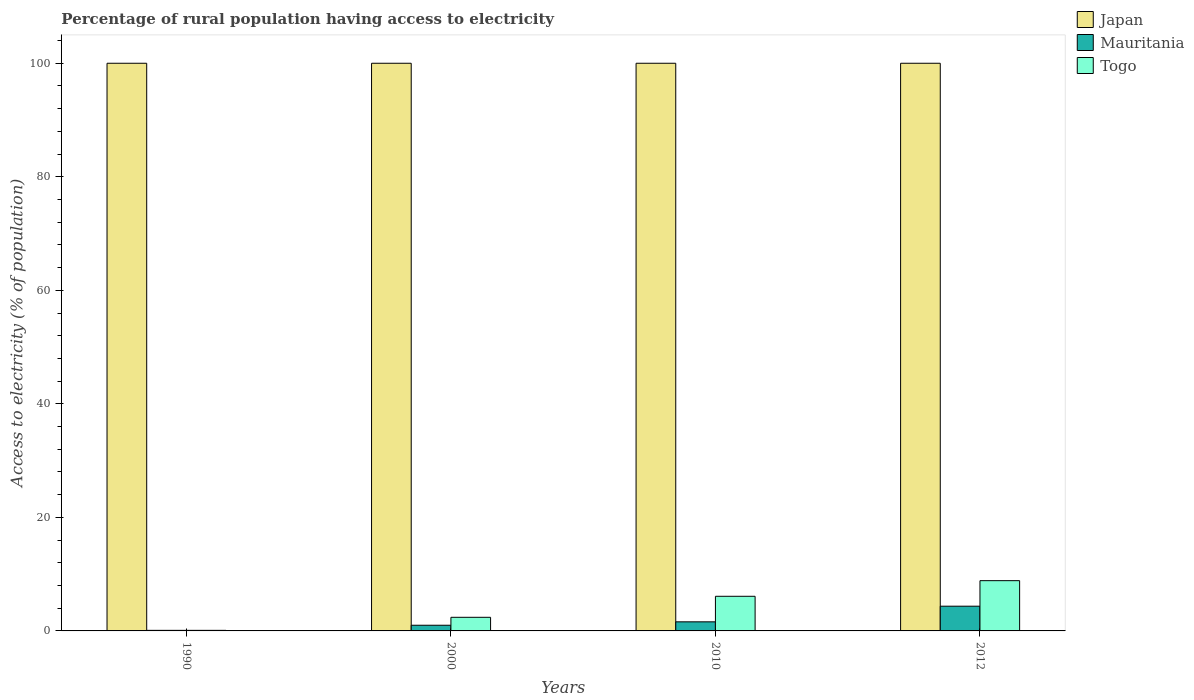How many different coloured bars are there?
Provide a succinct answer. 3. Are the number of bars on each tick of the X-axis equal?
Offer a terse response. Yes. How many bars are there on the 1st tick from the right?
Keep it short and to the point. 3. What is the label of the 1st group of bars from the left?
Your response must be concise. 1990. In how many cases, is the number of bars for a given year not equal to the number of legend labels?
Offer a terse response. 0. Across all years, what is the maximum percentage of rural population having access to electricity in Japan?
Keep it short and to the point. 100. Across all years, what is the minimum percentage of rural population having access to electricity in Japan?
Your answer should be very brief. 100. What is the total percentage of rural population having access to electricity in Japan in the graph?
Ensure brevity in your answer.  400. What is the difference between the percentage of rural population having access to electricity in Japan in 1990 and that in 2012?
Your response must be concise. 0. What is the difference between the percentage of rural population having access to electricity in Togo in 2000 and the percentage of rural population having access to electricity in Japan in 2012?
Your answer should be very brief. -97.6. What is the average percentage of rural population having access to electricity in Togo per year?
Your answer should be compact. 4.36. In the year 2000, what is the difference between the percentage of rural population having access to electricity in Mauritania and percentage of rural population having access to electricity in Japan?
Make the answer very short. -99. In how many years, is the percentage of rural population having access to electricity in Togo greater than 88 %?
Make the answer very short. 0. What is the ratio of the percentage of rural population having access to electricity in Togo in 1990 to that in 2012?
Provide a succinct answer. 0.01. Is the percentage of rural population having access to electricity in Mauritania in 2000 less than that in 2010?
Offer a very short reply. Yes. What is the difference between the highest and the second highest percentage of rural population having access to electricity in Japan?
Provide a succinct answer. 0. What is the difference between the highest and the lowest percentage of rural population having access to electricity in Mauritania?
Offer a very short reply. 4.25. In how many years, is the percentage of rural population having access to electricity in Togo greater than the average percentage of rural population having access to electricity in Togo taken over all years?
Ensure brevity in your answer.  2. Is the sum of the percentage of rural population having access to electricity in Togo in 2010 and 2012 greater than the maximum percentage of rural population having access to electricity in Japan across all years?
Offer a very short reply. No. What does the 2nd bar from the left in 2000 represents?
Make the answer very short. Mauritania. What does the 1st bar from the right in 1990 represents?
Provide a succinct answer. Togo. Is it the case that in every year, the sum of the percentage of rural population having access to electricity in Japan and percentage of rural population having access to electricity in Togo is greater than the percentage of rural population having access to electricity in Mauritania?
Provide a short and direct response. Yes. How many bars are there?
Give a very brief answer. 12. How many years are there in the graph?
Offer a terse response. 4. What is the difference between two consecutive major ticks on the Y-axis?
Offer a very short reply. 20. What is the title of the graph?
Offer a terse response. Percentage of rural population having access to electricity. Does "Seychelles" appear as one of the legend labels in the graph?
Give a very brief answer. No. What is the label or title of the Y-axis?
Provide a succinct answer. Access to electricity (% of population). What is the Access to electricity (% of population) in Togo in 1990?
Your response must be concise. 0.1. What is the Access to electricity (% of population) of Togo in 2000?
Your answer should be compact. 2.4. What is the Access to electricity (% of population) in Mauritania in 2010?
Give a very brief answer. 1.6. What is the Access to electricity (% of population) of Togo in 2010?
Provide a succinct answer. 6.1. What is the Access to electricity (% of population) of Japan in 2012?
Ensure brevity in your answer.  100. What is the Access to electricity (% of population) of Mauritania in 2012?
Ensure brevity in your answer.  4.35. What is the Access to electricity (% of population) of Togo in 2012?
Your answer should be very brief. 8.85. Across all years, what is the maximum Access to electricity (% of population) of Mauritania?
Make the answer very short. 4.35. Across all years, what is the maximum Access to electricity (% of population) in Togo?
Offer a terse response. 8.85. What is the total Access to electricity (% of population) in Japan in the graph?
Make the answer very short. 400. What is the total Access to electricity (% of population) in Mauritania in the graph?
Give a very brief answer. 7.05. What is the total Access to electricity (% of population) in Togo in the graph?
Ensure brevity in your answer.  17.45. What is the difference between the Access to electricity (% of population) in Japan in 1990 and that in 2000?
Your answer should be compact. 0. What is the difference between the Access to electricity (% of population) of Mauritania in 1990 and that in 2000?
Your answer should be compact. -0.9. What is the difference between the Access to electricity (% of population) of Mauritania in 1990 and that in 2010?
Keep it short and to the point. -1.5. What is the difference between the Access to electricity (% of population) in Togo in 1990 and that in 2010?
Provide a short and direct response. -6. What is the difference between the Access to electricity (% of population) in Japan in 1990 and that in 2012?
Your response must be concise. 0. What is the difference between the Access to electricity (% of population) of Mauritania in 1990 and that in 2012?
Offer a terse response. -4.25. What is the difference between the Access to electricity (% of population) of Togo in 1990 and that in 2012?
Provide a succinct answer. -8.75. What is the difference between the Access to electricity (% of population) in Japan in 2000 and that in 2010?
Offer a terse response. 0. What is the difference between the Access to electricity (% of population) in Mauritania in 2000 and that in 2010?
Offer a very short reply. -0.6. What is the difference between the Access to electricity (% of population) of Mauritania in 2000 and that in 2012?
Your response must be concise. -3.35. What is the difference between the Access to electricity (% of population) of Togo in 2000 and that in 2012?
Give a very brief answer. -6.45. What is the difference between the Access to electricity (% of population) in Japan in 2010 and that in 2012?
Your answer should be compact. 0. What is the difference between the Access to electricity (% of population) in Mauritania in 2010 and that in 2012?
Offer a very short reply. -2.75. What is the difference between the Access to electricity (% of population) in Togo in 2010 and that in 2012?
Your response must be concise. -2.75. What is the difference between the Access to electricity (% of population) of Japan in 1990 and the Access to electricity (% of population) of Mauritania in 2000?
Provide a short and direct response. 99. What is the difference between the Access to electricity (% of population) in Japan in 1990 and the Access to electricity (% of population) in Togo in 2000?
Offer a very short reply. 97.6. What is the difference between the Access to electricity (% of population) of Mauritania in 1990 and the Access to electricity (% of population) of Togo in 2000?
Make the answer very short. -2.3. What is the difference between the Access to electricity (% of population) of Japan in 1990 and the Access to electricity (% of population) of Mauritania in 2010?
Your answer should be very brief. 98.4. What is the difference between the Access to electricity (% of population) in Japan in 1990 and the Access to electricity (% of population) in Togo in 2010?
Give a very brief answer. 93.9. What is the difference between the Access to electricity (% of population) in Japan in 1990 and the Access to electricity (% of population) in Mauritania in 2012?
Your response must be concise. 95.65. What is the difference between the Access to electricity (% of population) of Japan in 1990 and the Access to electricity (% of population) of Togo in 2012?
Provide a short and direct response. 91.15. What is the difference between the Access to electricity (% of population) of Mauritania in 1990 and the Access to electricity (% of population) of Togo in 2012?
Your response must be concise. -8.75. What is the difference between the Access to electricity (% of population) in Japan in 2000 and the Access to electricity (% of population) in Mauritania in 2010?
Provide a succinct answer. 98.4. What is the difference between the Access to electricity (% of population) in Japan in 2000 and the Access to electricity (% of population) in Togo in 2010?
Your response must be concise. 93.9. What is the difference between the Access to electricity (% of population) in Japan in 2000 and the Access to electricity (% of population) in Mauritania in 2012?
Keep it short and to the point. 95.65. What is the difference between the Access to electricity (% of population) of Japan in 2000 and the Access to electricity (% of population) of Togo in 2012?
Offer a very short reply. 91.15. What is the difference between the Access to electricity (% of population) of Mauritania in 2000 and the Access to electricity (% of population) of Togo in 2012?
Your response must be concise. -7.85. What is the difference between the Access to electricity (% of population) in Japan in 2010 and the Access to electricity (% of population) in Mauritania in 2012?
Provide a succinct answer. 95.65. What is the difference between the Access to electricity (% of population) of Japan in 2010 and the Access to electricity (% of population) of Togo in 2012?
Your answer should be very brief. 91.15. What is the difference between the Access to electricity (% of population) of Mauritania in 2010 and the Access to electricity (% of population) of Togo in 2012?
Keep it short and to the point. -7.25. What is the average Access to electricity (% of population) in Japan per year?
Ensure brevity in your answer.  100. What is the average Access to electricity (% of population) in Mauritania per year?
Provide a succinct answer. 1.76. What is the average Access to electricity (% of population) of Togo per year?
Keep it short and to the point. 4.36. In the year 1990, what is the difference between the Access to electricity (% of population) of Japan and Access to electricity (% of population) of Mauritania?
Offer a very short reply. 99.9. In the year 1990, what is the difference between the Access to electricity (% of population) of Japan and Access to electricity (% of population) of Togo?
Make the answer very short. 99.9. In the year 1990, what is the difference between the Access to electricity (% of population) of Mauritania and Access to electricity (% of population) of Togo?
Provide a succinct answer. 0. In the year 2000, what is the difference between the Access to electricity (% of population) in Japan and Access to electricity (% of population) in Togo?
Offer a very short reply. 97.6. In the year 2010, what is the difference between the Access to electricity (% of population) of Japan and Access to electricity (% of population) of Mauritania?
Offer a very short reply. 98.4. In the year 2010, what is the difference between the Access to electricity (% of population) in Japan and Access to electricity (% of population) in Togo?
Provide a short and direct response. 93.9. In the year 2010, what is the difference between the Access to electricity (% of population) in Mauritania and Access to electricity (% of population) in Togo?
Keep it short and to the point. -4.5. In the year 2012, what is the difference between the Access to electricity (% of population) of Japan and Access to electricity (% of population) of Mauritania?
Ensure brevity in your answer.  95.65. In the year 2012, what is the difference between the Access to electricity (% of population) of Japan and Access to electricity (% of population) of Togo?
Your answer should be very brief. 91.15. In the year 2012, what is the difference between the Access to electricity (% of population) of Mauritania and Access to electricity (% of population) of Togo?
Keep it short and to the point. -4.5. What is the ratio of the Access to electricity (% of population) of Japan in 1990 to that in 2000?
Keep it short and to the point. 1. What is the ratio of the Access to electricity (% of population) in Togo in 1990 to that in 2000?
Offer a terse response. 0.04. What is the ratio of the Access to electricity (% of population) in Mauritania in 1990 to that in 2010?
Make the answer very short. 0.06. What is the ratio of the Access to electricity (% of population) of Togo in 1990 to that in 2010?
Offer a terse response. 0.02. What is the ratio of the Access to electricity (% of population) in Japan in 1990 to that in 2012?
Keep it short and to the point. 1. What is the ratio of the Access to electricity (% of population) of Mauritania in 1990 to that in 2012?
Keep it short and to the point. 0.02. What is the ratio of the Access to electricity (% of population) in Togo in 1990 to that in 2012?
Make the answer very short. 0.01. What is the ratio of the Access to electricity (% of population) in Togo in 2000 to that in 2010?
Your answer should be very brief. 0.39. What is the ratio of the Access to electricity (% of population) of Japan in 2000 to that in 2012?
Your answer should be compact. 1. What is the ratio of the Access to electricity (% of population) in Mauritania in 2000 to that in 2012?
Provide a short and direct response. 0.23. What is the ratio of the Access to electricity (% of population) of Togo in 2000 to that in 2012?
Your answer should be compact. 0.27. What is the ratio of the Access to electricity (% of population) in Mauritania in 2010 to that in 2012?
Make the answer very short. 0.37. What is the ratio of the Access to electricity (% of population) in Togo in 2010 to that in 2012?
Keep it short and to the point. 0.69. What is the difference between the highest and the second highest Access to electricity (% of population) in Japan?
Your answer should be compact. 0. What is the difference between the highest and the second highest Access to electricity (% of population) of Mauritania?
Offer a very short reply. 2.75. What is the difference between the highest and the second highest Access to electricity (% of population) of Togo?
Offer a very short reply. 2.75. What is the difference between the highest and the lowest Access to electricity (% of population) in Japan?
Offer a terse response. 0. What is the difference between the highest and the lowest Access to electricity (% of population) in Mauritania?
Keep it short and to the point. 4.25. What is the difference between the highest and the lowest Access to electricity (% of population) of Togo?
Your response must be concise. 8.75. 